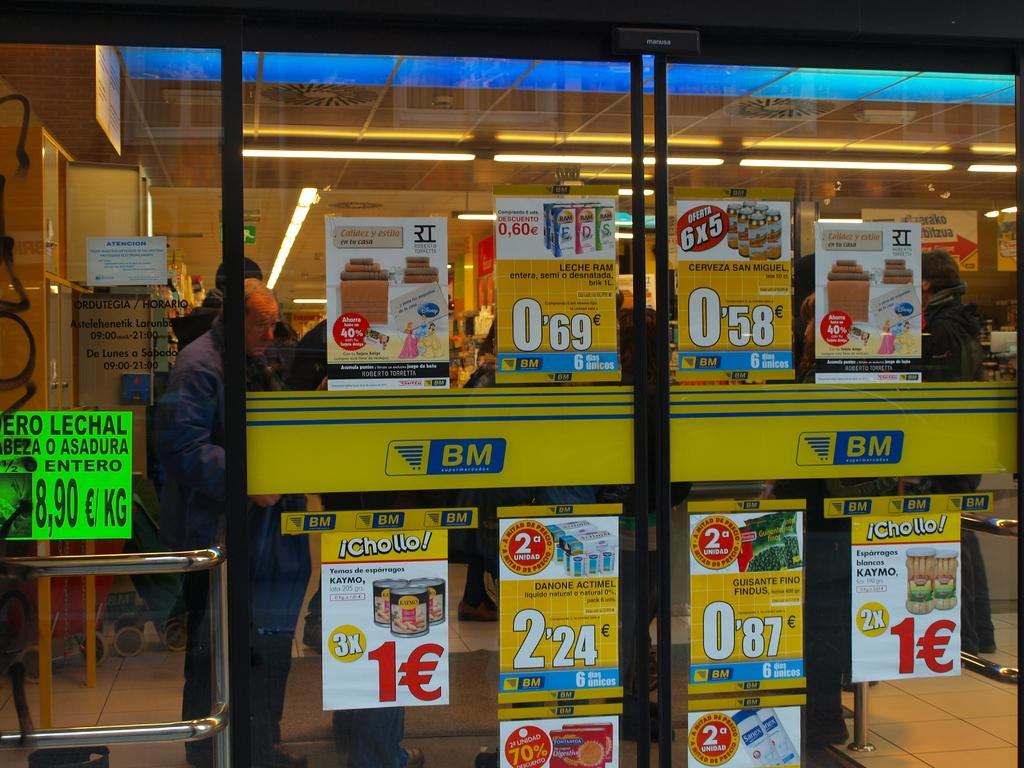<image>
Create a compact narrative representing the image presented. An add for Chollo and Danote Actimel are on a store window. 